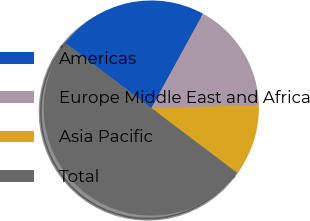Convert chart to OTSL. <chart><loc_0><loc_0><loc_500><loc_500><pie_chart><fcel>Americas<fcel>Europe Middle East and Africa<fcel>Asia Pacific<fcel>Total<nl><fcel>22.69%<fcel>16.58%<fcel>10.73%<fcel>50.0%<nl></chart> 